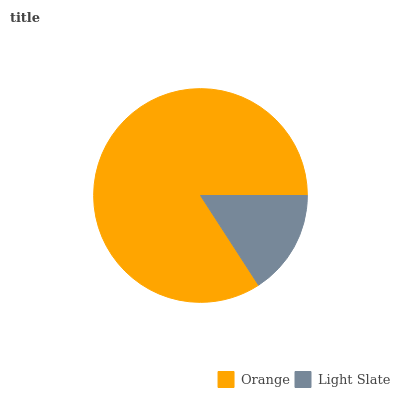Is Light Slate the minimum?
Answer yes or no. Yes. Is Orange the maximum?
Answer yes or no. Yes. Is Light Slate the maximum?
Answer yes or no. No. Is Orange greater than Light Slate?
Answer yes or no. Yes. Is Light Slate less than Orange?
Answer yes or no. Yes. Is Light Slate greater than Orange?
Answer yes or no. No. Is Orange less than Light Slate?
Answer yes or no. No. Is Orange the high median?
Answer yes or no. Yes. Is Light Slate the low median?
Answer yes or no. Yes. Is Light Slate the high median?
Answer yes or no. No. Is Orange the low median?
Answer yes or no. No. 